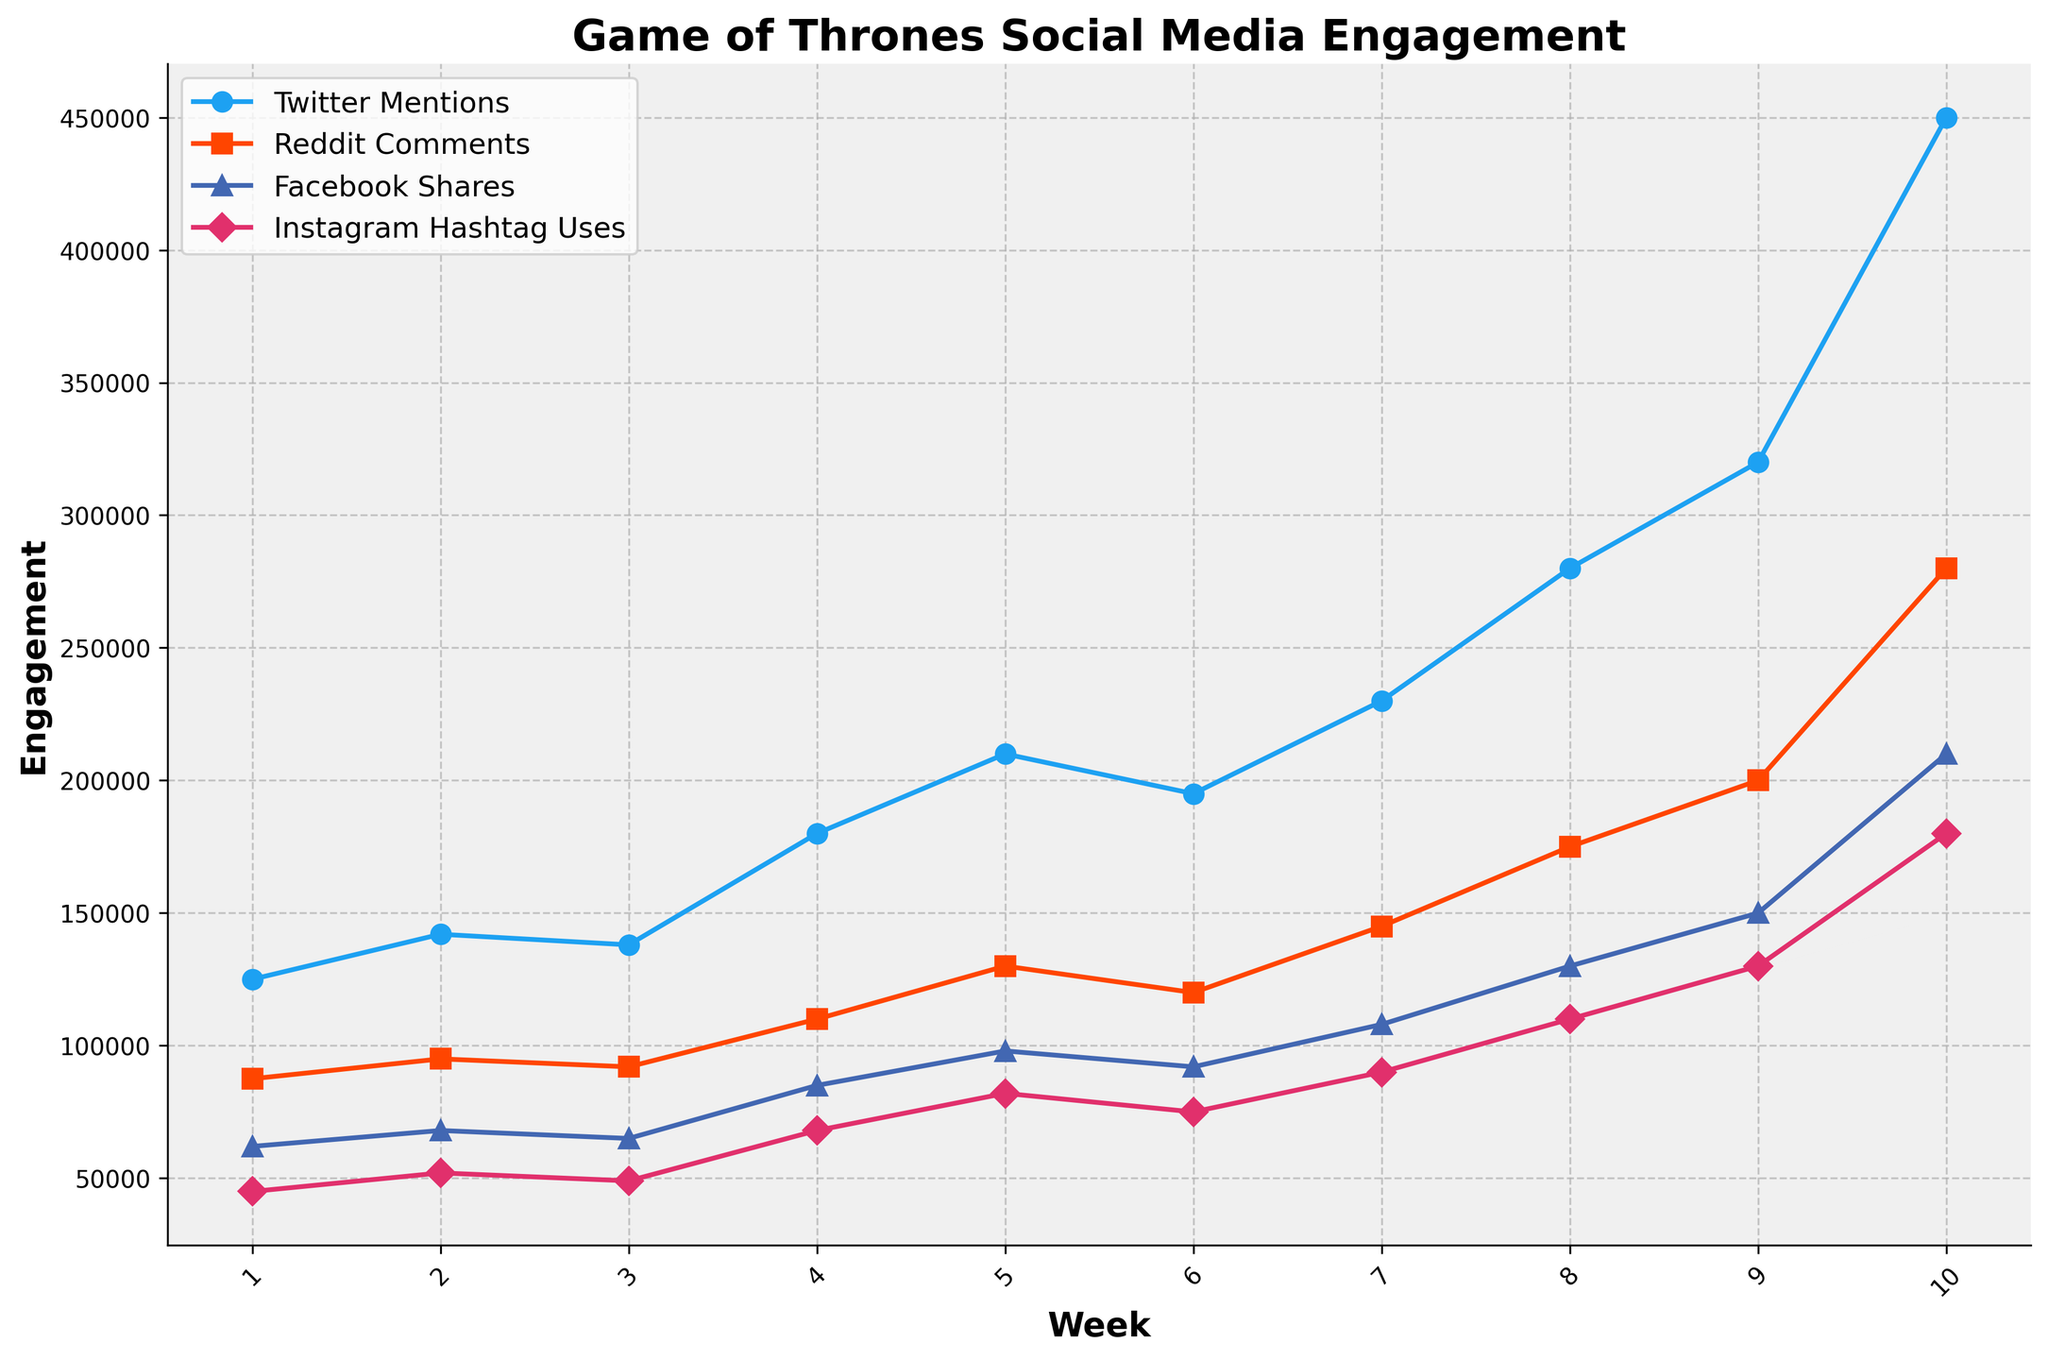Which social media channel had the highest spike in engagement in Week 10? In Week 10, you can see that YouTube Views had a significant increase compared to previous weeks. This is evident from the steep rise in the line representing YouTube Views, reaching 6,500,000.
Answer: YouTube Views How much higher were Instagram Hashtag Uses in Week 10 compared to Week 5? Instagram Hashtag Uses in Week 10 were 180,000 while in Week 5 they were 82,000. The difference is calculated as 180,000 - 82,000.
Answer: 98,000 Between Twitter Mentions and Reddit Comments, which had a higher average engagement over the 10 weeks? Sum Twitter Mentions over 10 weeks: 125,000 + 142,000 + 138,000 + 180,000 + 210,000 + 195,000 + 230,000 + 280,000 + 320,000 + 450,000 = 2,270,000. Average = 2,270,000 / 10 = 227,000. Sum Reddit Comments over 10 weeks: 87,500 + 95,000 + 92,000 + 110,000 + 130,000 + 120,000 + 145,000 + 175,000 + 200,000 + 280,000 = 1,434,500. Average = 1,434,500 / 10 = 143,450.
Answer: Twitter Mentions How did Facebook Shares change from Week 1 to Week 4? Facebook Shares in Week 1 were 62,000 and in Week 4 they were 85,000. The difference is calculated as 85,000 - 62,000, showing an increase over these weeks.
Answer: Increased by 23,000 Which social media metric had the most consistent growth throughout the show's run? By examining the slopes of the lines over time, Instagram Hashtag Uses show the most consistent upward trajectory without dramatic spikes or dips, steadily increasing from 45,000 in Week 1 to 180,000 in Week 10.
Answer: Instagram Hashtag Uses In which week did Twitter Mentions surpass 200,000 for the first time? By observing the line representing Twitter Mentions, it first surpasses 200,000 in Week 5, evidenced by the data point of 210,000.
Answer: Week 5 What is the total increase in YouTube Views from Week 1 to Week 10? YouTube Views in Week 1 were 2,100,000 and in Week 10 they were 6,500,000. The difference is calculated as 6,500,000 - 2,100,000, indicating the total increase.
Answer: 4,400,000 Which two weeks showed the greatest increase in Reddit Comments, and by how much did they increase? The greatest increase in Reddit Comments appears between weeks 9 and 10. Reddit Comments in Week 9 were 200,000 and in Week 10 they were 280,000. The difference is calculated as 280,000 - 200,000.
Answer: Weeks 9 and 10; Increase by 80,000 By what percent did Facebook Shares increase from Week 8 to Week 9? Facebook Shares in Week 8 were 130,000 and in Week 9 they were 150,000. The percentage increase is ((150,000 - 130,000) / 130,000) * 100%.
Answer: 15.38% From the visual data, which social media metric had the largest variance over the 10 weeks? Observing the spread and changes of each line, YouTube Views shows the largest jumps, ranging from 2,100,000 to 6,500,000, indicating the highest variance over the weeks.
Answer: YouTube Views 